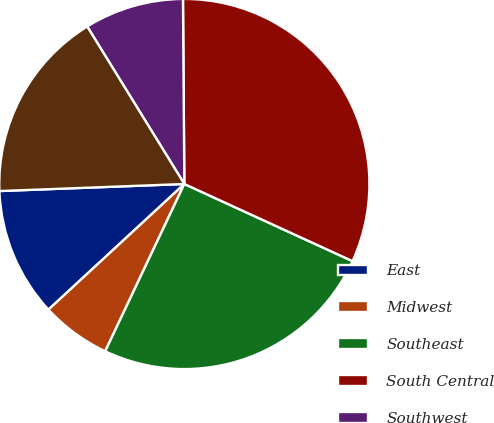Convert chart to OTSL. <chart><loc_0><loc_0><loc_500><loc_500><pie_chart><fcel>East<fcel>Midwest<fcel>Southeast<fcel>South Central<fcel>Southwest<fcel>West<nl><fcel>11.27%<fcel>6.09%<fcel>25.19%<fcel>31.96%<fcel>8.68%<fcel>16.81%<nl></chart> 